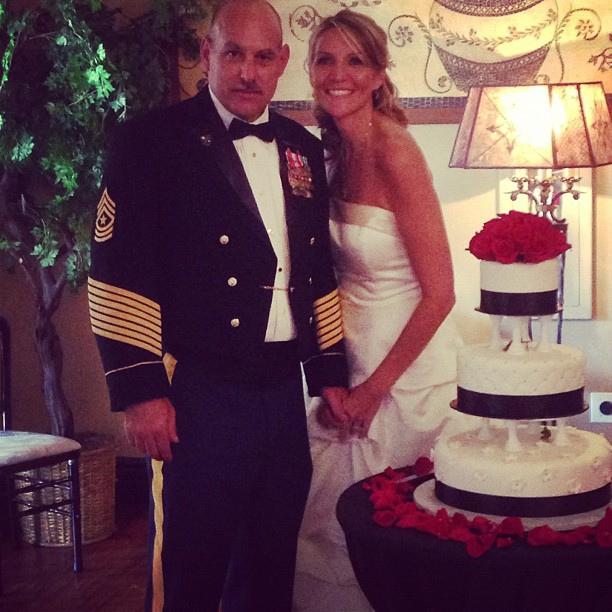What's on top of the cake?
Quick response, please. Roses. What is the bride doing?
Keep it brief. Smiling. How many buttons on the jacket?
Write a very short answer. 3. What color is the wedding cake?
Quick response, please. White. What does the man wear to denote his culture?
Quick response, please. Uniform. Are any lights on?
Give a very brief answer. Yes. 